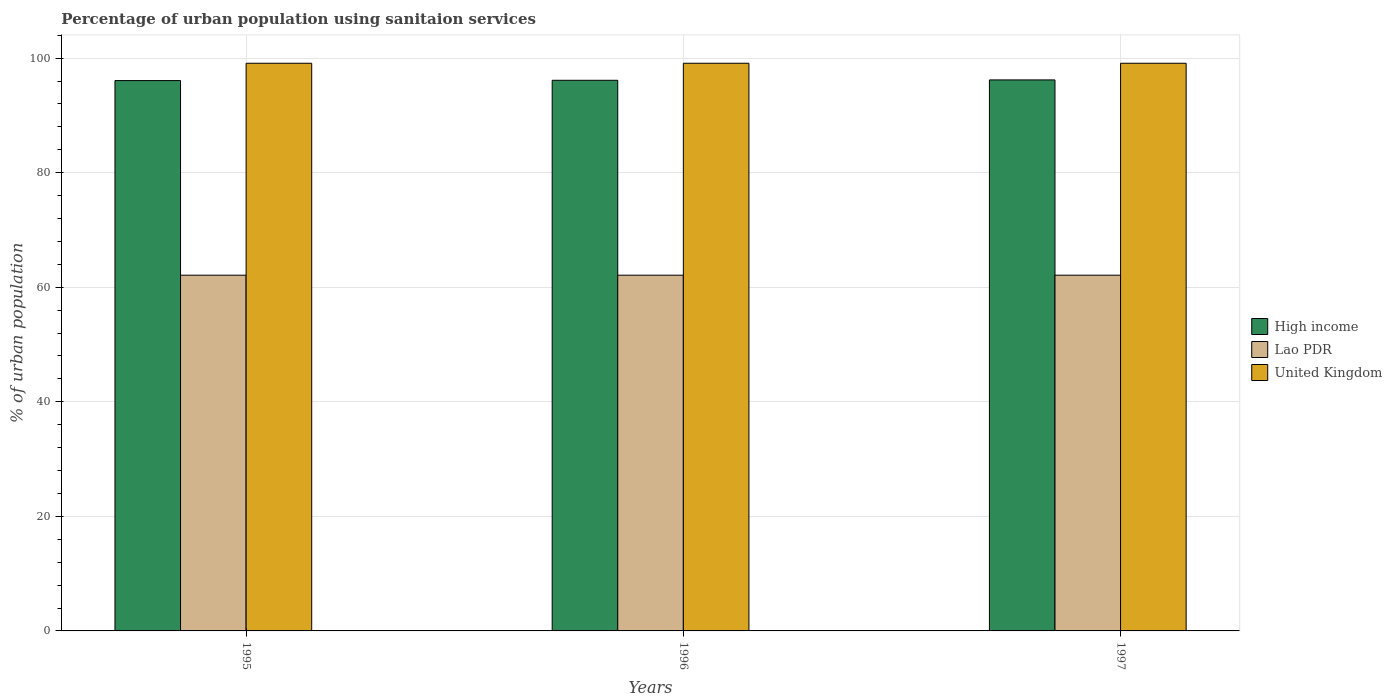How many different coloured bars are there?
Provide a succinct answer. 3. How many groups of bars are there?
Your response must be concise. 3. Are the number of bars per tick equal to the number of legend labels?
Make the answer very short. Yes. How many bars are there on the 2nd tick from the right?
Provide a short and direct response. 3. What is the label of the 1st group of bars from the left?
Keep it short and to the point. 1995. What is the percentage of urban population using sanitaion services in High income in 1996?
Your response must be concise. 96.13. Across all years, what is the maximum percentage of urban population using sanitaion services in Lao PDR?
Ensure brevity in your answer.  62.1. Across all years, what is the minimum percentage of urban population using sanitaion services in Lao PDR?
Make the answer very short. 62.1. What is the total percentage of urban population using sanitaion services in Lao PDR in the graph?
Provide a succinct answer. 186.3. What is the difference between the percentage of urban population using sanitaion services in High income in 1995 and that in 1996?
Provide a short and direct response. -0.05. What is the difference between the percentage of urban population using sanitaion services in Lao PDR in 1997 and the percentage of urban population using sanitaion services in High income in 1996?
Keep it short and to the point. -34.03. What is the average percentage of urban population using sanitaion services in High income per year?
Keep it short and to the point. 96.13. In the year 1995, what is the difference between the percentage of urban population using sanitaion services in Lao PDR and percentage of urban population using sanitaion services in United Kingdom?
Provide a short and direct response. -37. Is the percentage of urban population using sanitaion services in United Kingdom in 1996 less than that in 1997?
Keep it short and to the point. No. What is the difference between the highest and the second highest percentage of urban population using sanitaion services in United Kingdom?
Offer a very short reply. 0. What is the difference between the highest and the lowest percentage of urban population using sanitaion services in High income?
Ensure brevity in your answer.  0.12. In how many years, is the percentage of urban population using sanitaion services in United Kingdom greater than the average percentage of urban population using sanitaion services in United Kingdom taken over all years?
Provide a succinct answer. 3. How many years are there in the graph?
Make the answer very short. 3. What is the difference between two consecutive major ticks on the Y-axis?
Give a very brief answer. 20. Are the values on the major ticks of Y-axis written in scientific E-notation?
Keep it short and to the point. No. How many legend labels are there?
Keep it short and to the point. 3. What is the title of the graph?
Offer a terse response. Percentage of urban population using sanitaion services. Does "Low income" appear as one of the legend labels in the graph?
Give a very brief answer. No. What is the label or title of the X-axis?
Offer a very short reply. Years. What is the label or title of the Y-axis?
Make the answer very short. % of urban population. What is the % of urban population in High income in 1995?
Your answer should be very brief. 96.07. What is the % of urban population of Lao PDR in 1995?
Your answer should be very brief. 62.1. What is the % of urban population of United Kingdom in 1995?
Your answer should be very brief. 99.1. What is the % of urban population in High income in 1996?
Make the answer very short. 96.13. What is the % of urban population in Lao PDR in 1996?
Offer a very short reply. 62.1. What is the % of urban population of United Kingdom in 1996?
Your answer should be very brief. 99.1. What is the % of urban population in High income in 1997?
Your response must be concise. 96.19. What is the % of urban population in Lao PDR in 1997?
Provide a succinct answer. 62.1. What is the % of urban population in United Kingdom in 1997?
Ensure brevity in your answer.  99.1. Across all years, what is the maximum % of urban population in High income?
Provide a succinct answer. 96.19. Across all years, what is the maximum % of urban population of Lao PDR?
Your answer should be compact. 62.1. Across all years, what is the maximum % of urban population of United Kingdom?
Your response must be concise. 99.1. Across all years, what is the minimum % of urban population in High income?
Your answer should be compact. 96.07. Across all years, what is the minimum % of urban population in Lao PDR?
Provide a short and direct response. 62.1. Across all years, what is the minimum % of urban population of United Kingdom?
Provide a short and direct response. 99.1. What is the total % of urban population in High income in the graph?
Offer a terse response. 288.39. What is the total % of urban population in Lao PDR in the graph?
Give a very brief answer. 186.3. What is the total % of urban population in United Kingdom in the graph?
Ensure brevity in your answer.  297.3. What is the difference between the % of urban population in High income in 1995 and that in 1996?
Make the answer very short. -0.05. What is the difference between the % of urban population of Lao PDR in 1995 and that in 1996?
Your answer should be very brief. 0. What is the difference between the % of urban population of United Kingdom in 1995 and that in 1996?
Ensure brevity in your answer.  0. What is the difference between the % of urban population in High income in 1995 and that in 1997?
Your answer should be very brief. -0.12. What is the difference between the % of urban population of High income in 1996 and that in 1997?
Make the answer very short. -0.06. What is the difference between the % of urban population in High income in 1995 and the % of urban population in Lao PDR in 1996?
Provide a short and direct response. 33.97. What is the difference between the % of urban population in High income in 1995 and the % of urban population in United Kingdom in 1996?
Your answer should be very brief. -3.03. What is the difference between the % of urban population of Lao PDR in 1995 and the % of urban population of United Kingdom in 1996?
Ensure brevity in your answer.  -37. What is the difference between the % of urban population of High income in 1995 and the % of urban population of Lao PDR in 1997?
Provide a short and direct response. 33.97. What is the difference between the % of urban population of High income in 1995 and the % of urban population of United Kingdom in 1997?
Make the answer very short. -3.03. What is the difference between the % of urban population of Lao PDR in 1995 and the % of urban population of United Kingdom in 1997?
Keep it short and to the point. -37. What is the difference between the % of urban population of High income in 1996 and the % of urban population of Lao PDR in 1997?
Provide a succinct answer. 34.03. What is the difference between the % of urban population of High income in 1996 and the % of urban population of United Kingdom in 1997?
Make the answer very short. -2.97. What is the difference between the % of urban population of Lao PDR in 1996 and the % of urban population of United Kingdom in 1997?
Provide a succinct answer. -37. What is the average % of urban population in High income per year?
Your answer should be very brief. 96.13. What is the average % of urban population of Lao PDR per year?
Give a very brief answer. 62.1. What is the average % of urban population of United Kingdom per year?
Provide a succinct answer. 99.1. In the year 1995, what is the difference between the % of urban population in High income and % of urban population in Lao PDR?
Your answer should be compact. 33.97. In the year 1995, what is the difference between the % of urban population in High income and % of urban population in United Kingdom?
Provide a short and direct response. -3.03. In the year 1995, what is the difference between the % of urban population of Lao PDR and % of urban population of United Kingdom?
Provide a short and direct response. -37. In the year 1996, what is the difference between the % of urban population of High income and % of urban population of Lao PDR?
Your answer should be compact. 34.03. In the year 1996, what is the difference between the % of urban population in High income and % of urban population in United Kingdom?
Give a very brief answer. -2.97. In the year 1996, what is the difference between the % of urban population of Lao PDR and % of urban population of United Kingdom?
Give a very brief answer. -37. In the year 1997, what is the difference between the % of urban population of High income and % of urban population of Lao PDR?
Ensure brevity in your answer.  34.09. In the year 1997, what is the difference between the % of urban population in High income and % of urban population in United Kingdom?
Keep it short and to the point. -2.91. In the year 1997, what is the difference between the % of urban population in Lao PDR and % of urban population in United Kingdom?
Offer a very short reply. -37. What is the ratio of the % of urban population of High income in 1995 to that in 1996?
Offer a very short reply. 1. What is the ratio of the % of urban population in United Kingdom in 1995 to that in 1996?
Keep it short and to the point. 1. What is the ratio of the % of urban population of High income in 1995 to that in 1997?
Make the answer very short. 1. What is the ratio of the % of urban population in United Kingdom in 1995 to that in 1997?
Provide a succinct answer. 1. What is the ratio of the % of urban population in Lao PDR in 1996 to that in 1997?
Ensure brevity in your answer.  1. What is the ratio of the % of urban population in United Kingdom in 1996 to that in 1997?
Ensure brevity in your answer.  1. What is the difference between the highest and the second highest % of urban population in High income?
Provide a succinct answer. 0.06. What is the difference between the highest and the second highest % of urban population of Lao PDR?
Offer a very short reply. 0. What is the difference between the highest and the lowest % of urban population of High income?
Your response must be concise. 0.12. What is the difference between the highest and the lowest % of urban population of United Kingdom?
Offer a very short reply. 0. 